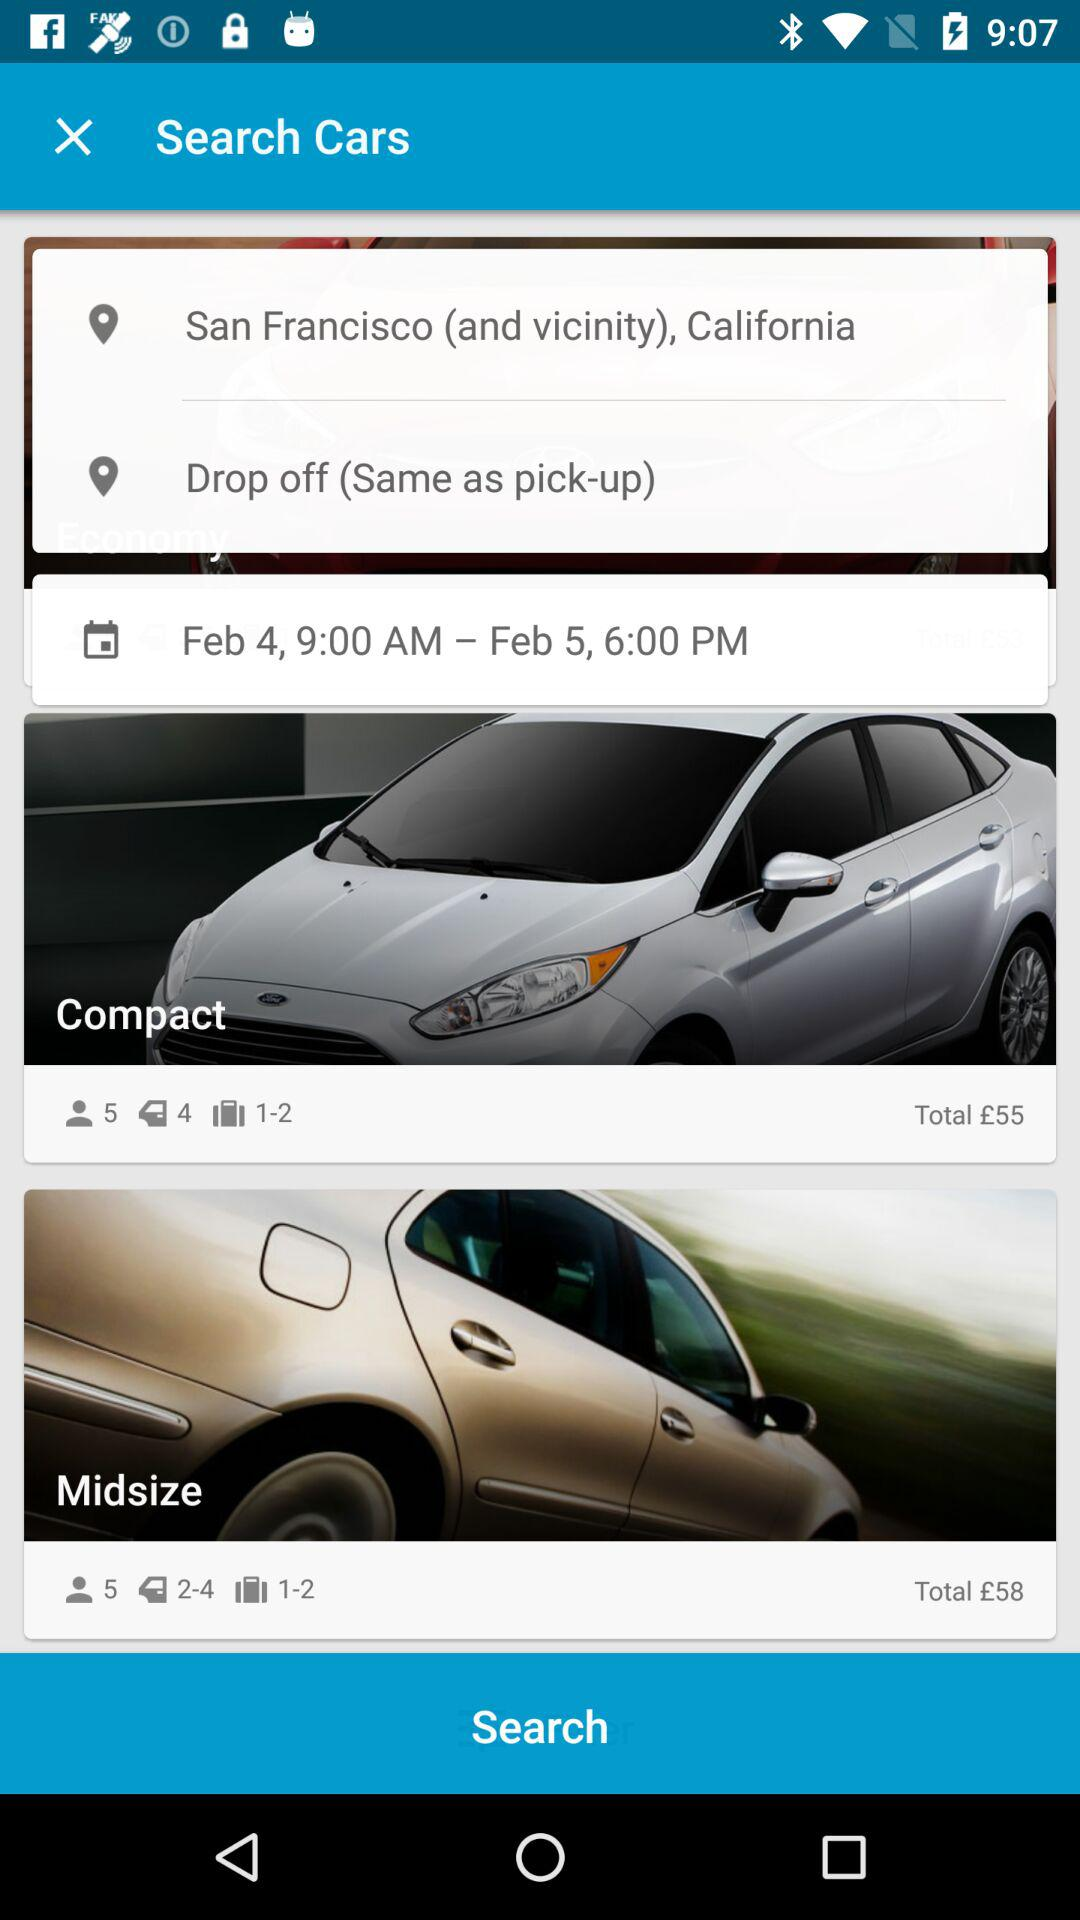What is the charge for the compact car? The charge for the compact car is £55. 